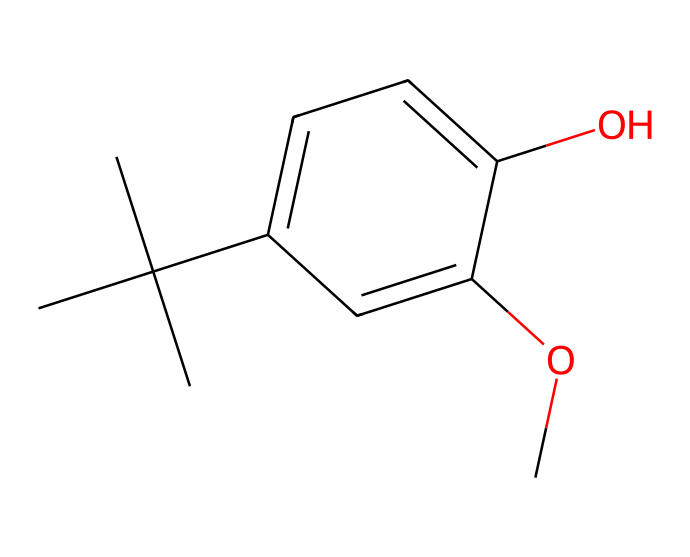What is the molecular formula of BHA? To determine the molecular formula from the SMILES representation, we can break down the structure for the elements. In this case, we count the carbon (C), hydrogen (H), and oxygen (O) atoms in the structure. The breakdown shows 11 carbon atoms, 14 hydrogen atoms, and 2 oxygen atoms, leading to the molecular formula C11H14O2.
Answer: C11H14O2 How many hydroxyl groups are present in BHA? The chemical structure contains a hydroxyl (-OH) group represented by an oxygen atom bonded to a carbon atom. By analyzing the structure, we can identify that there is one hydroxyl group present.
Answer: 1 What type of chemical is BHA classified as? BHA is classified as a phenolic antioxidant and is commonly used as a food additive to prevent oxidative rancidity. The presence of a phenolic structure (which includes the aromatic ring and the hydroxyl group) supports this classification.
Answer: phenolic antioxidant Does BHA have any double bonds? Identifying double bonds involves examining the carbon atoms in the structure. By visual inspection of the SMILES code, we see that all carbon atoms are bonded with single bonds, so there are no double bonds present in BHA.
Answer: no How many rings are in the structure of BHA? By examining the SMILES representation, we notice that there is no indication of a cyclic structure, as indicated by the absence of any ring closures in the syntax. Thus, BHA contains zero rings in its structure.
Answer: 0 Which functional group does BHA contain that contributes to its antioxidant properties? The chemical structure presents a phenolic hydroxyl functional group, which plays a significant role in the antioxidant properties by donating hydrogen atoms to free radicals, thus stabilizing them.
Answer: phenolic hydroxyl 